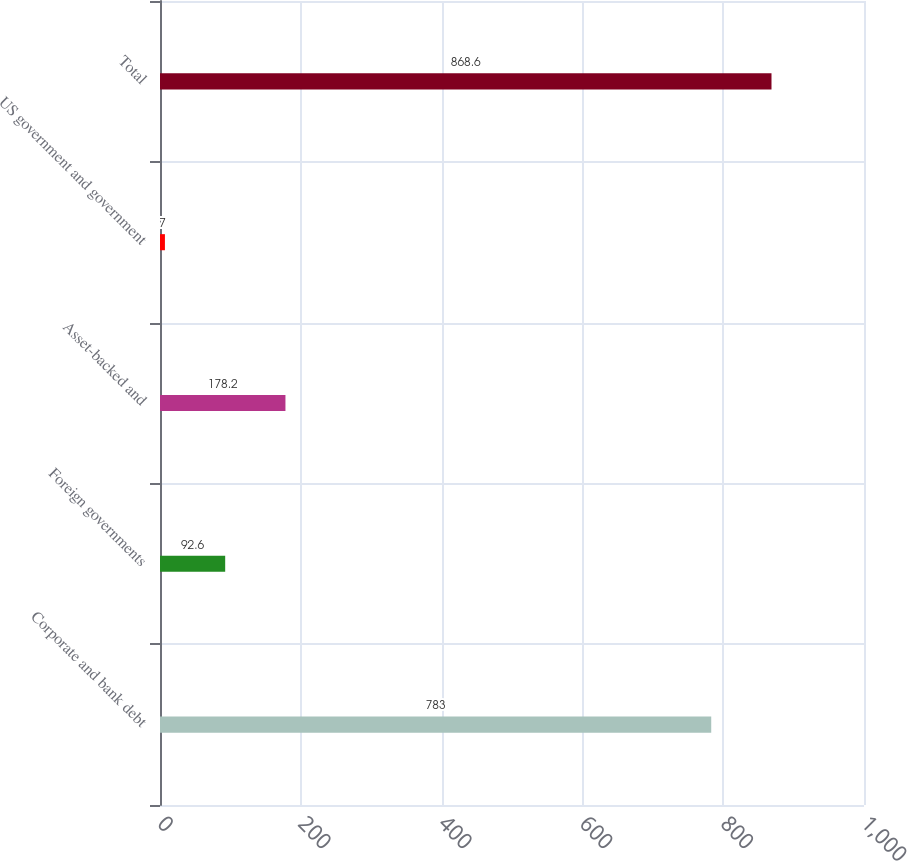<chart> <loc_0><loc_0><loc_500><loc_500><bar_chart><fcel>Corporate and bank debt<fcel>Foreign governments<fcel>Asset-backed and<fcel>US government and government<fcel>Total<nl><fcel>783<fcel>92.6<fcel>178.2<fcel>7<fcel>868.6<nl></chart> 